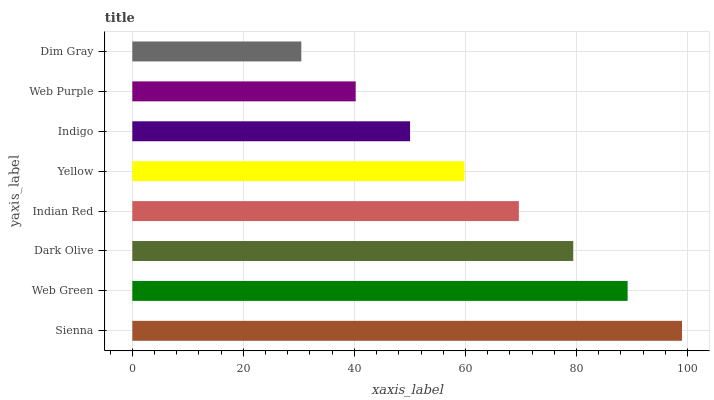Is Dim Gray the minimum?
Answer yes or no. Yes. Is Sienna the maximum?
Answer yes or no. Yes. Is Web Green the minimum?
Answer yes or no. No. Is Web Green the maximum?
Answer yes or no. No. Is Sienna greater than Web Green?
Answer yes or no. Yes. Is Web Green less than Sienna?
Answer yes or no. Yes. Is Web Green greater than Sienna?
Answer yes or no. No. Is Sienna less than Web Green?
Answer yes or no. No. Is Indian Red the high median?
Answer yes or no. Yes. Is Yellow the low median?
Answer yes or no. Yes. Is Yellow the high median?
Answer yes or no. No. Is Web Purple the low median?
Answer yes or no. No. 